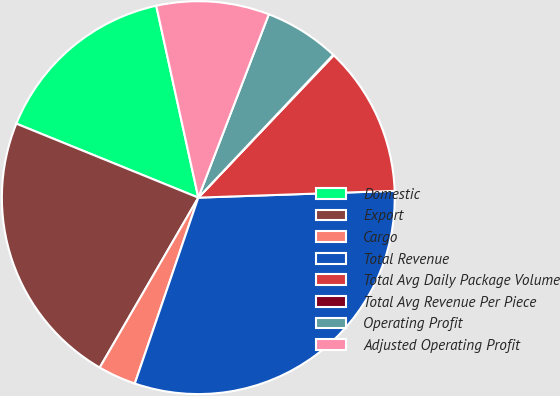Convert chart to OTSL. <chart><loc_0><loc_0><loc_500><loc_500><pie_chart><fcel>Domestic<fcel>Export<fcel>Cargo<fcel>Total Revenue<fcel>Total Avg Daily Package Volume<fcel>Total Avg Revenue Per Piece<fcel>Operating Profit<fcel>Adjusted Operating Profit<nl><fcel>15.42%<fcel>22.78%<fcel>3.13%<fcel>30.79%<fcel>12.35%<fcel>0.06%<fcel>6.2%<fcel>9.28%<nl></chart> 